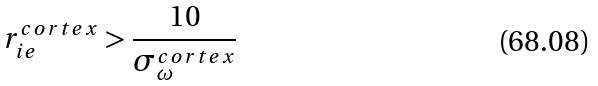<formula> <loc_0><loc_0><loc_500><loc_500>r _ { i e } ^ { c o r t e x } > \frac { 1 0 } { \sigma _ { \omega } ^ { c o r t e x } }</formula> 